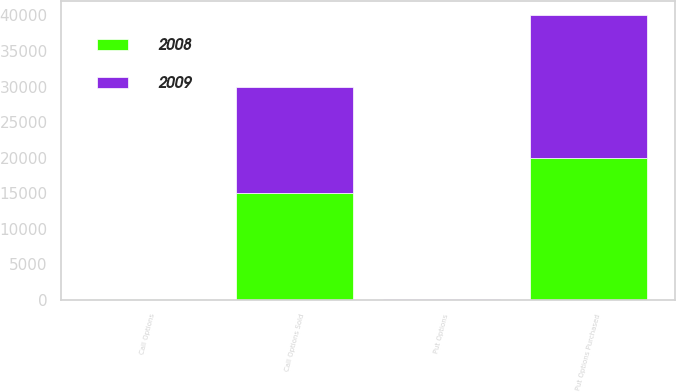<chart> <loc_0><loc_0><loc_500><loc_500><stacked_bar_chart><ecel><fcel>Put Options Purchased<fcel>Call Options Sold<fcel>Put Options<fcel>Call Options<nl><fcel>2008<fcel>20000<fcel>15000<fcel>54.25<fcel>94.25<nl><fcel>2009<fcel>20000<fcel>15000<fcel>50.5<fcel>90.5<nl></chart> 